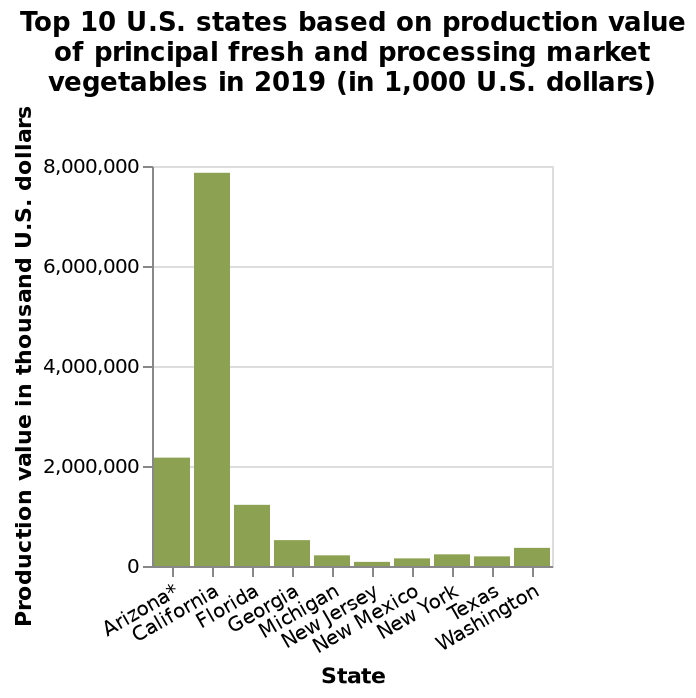<image>
please describe the details of the chart This bar diagram is labeled Top 10 U.S. states based on production value of principal fresh and processing market vegetables in 2019 (in 1,000 U.S. dollars). There is a categorical scale with Arizona* on one end and Washington at the other on the x-axis, marked State. Production value in thousand U.S. dollars is plotted on the y-axis. Which state is labeled at the other end of the x-axis? Washington is labeled at the other end of the x-axis. Which state has the biggest difference in production value between principal fresh and processing market vegetables? California has the biggest difference in production value between principal fresh and processing market vegetables. Which state has the highest production value of principal fresh and processing market vegetables?  California has the highest production value of principal fresh and processing market vegetables. 